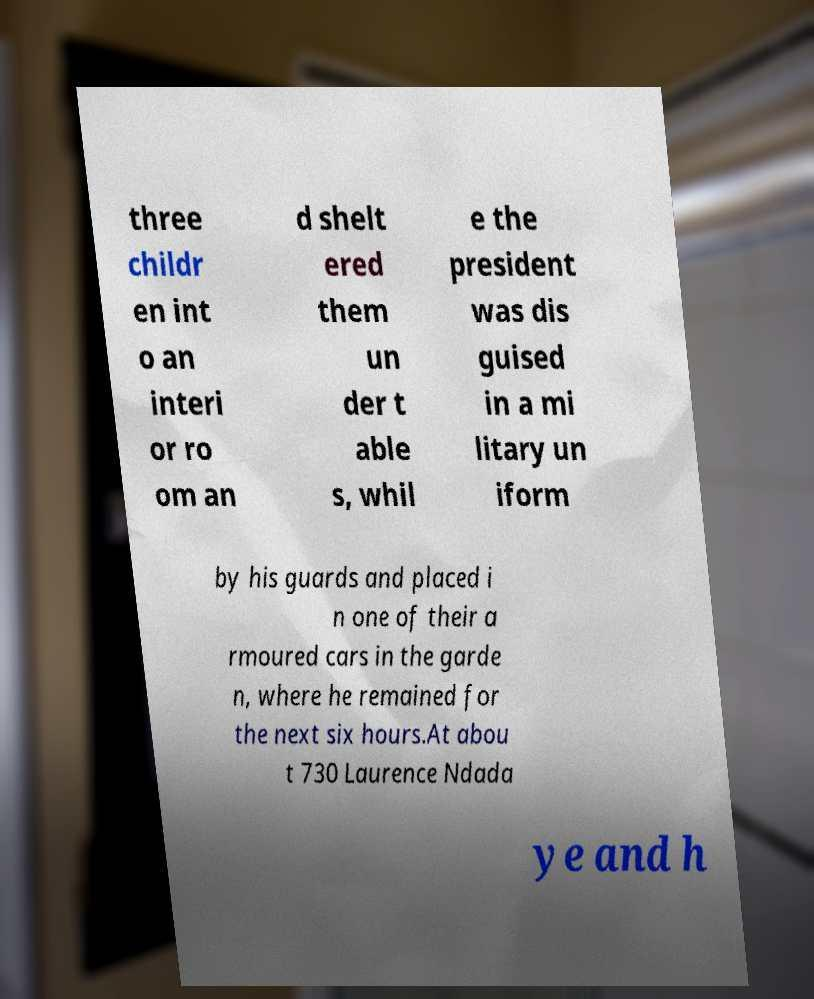What messages or text are displayed in this image? I need them in a readable, typed format. three childr en int o an interi or ro om an d shelt ered them un der t able s, whil e the president was dis guised in a mi litary un iform by his guards and placed i n one of their a rmoured cars in the garde n, where he remained for the next six hours.At abou t 730 Laurence Ndada ye and h 